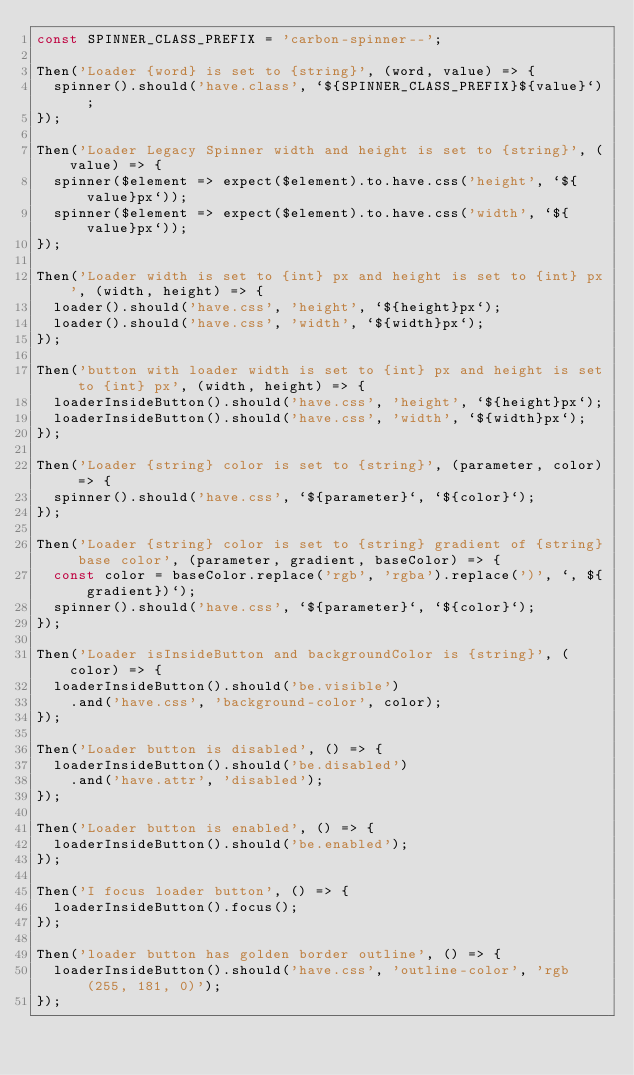Convert code to text. <code><loc_0><loc_0><loc_500><loc_500><_JavaScript_>const SPINNER_CLASS_PREFIX = 'carbon-spinner--';

Then('Loader {word} is set to {string}', (word, value) => {
  spinner().should('have.class', `${SPINNER_CLASS_PREFIX}${value}`);
});

Then('Loader Legacy Spinner width and height is set to {string}', (value) => {
  spinner($element => expect($element).to.have.css('height', `${value}px`));
  spinner($element => expect($element).to.have.css('width', `${value}px`));
});

Then('Loader width is set to {int} px and height is set to {int} px', (width, height) => {
  loader().should('have.css', 'height', `${height}px`);
  loader().should('have.css', 'width', `${width}px`);
});

Then('button with loader width is set to {int} px and height is set to {int} px', (width, height) => {
  loaderInsideButton().should('have.css', 'height', `${height}px`);
  loaderInsideButton().should('have.css', 'width', `${width}px`);
});

Then('Loader {string} color is set to {string}', (parameter, color) => {
  spinner().should('have.css', `${parameter}`, `${color}`);
});

Then('Loader {string} color is set to {string} gradient of {string} base color', (parameter, gradient, baseColor) => {
  const color = baseColor.replace('rgb', 'rgba').replace(')', `, ${gradient})`);
  spinner().should('have.css', `${parameter}`, `${color}`);
});

Then('Loader isInsideButton and backgroundColor is {string}', (color) => {
  loaderInsideButton().should('be.visible')
    .and('have.css', 'background-color', color);
});

Then('Loader button is disabled', () => {
  loaderInsideButton().should('be.disabled')
    .and('have.attr', 'disabled');
});

Then('Loader button is enabled', () => {
  loaderInsideButton().should('be.enabled');
});

Then('I focus loader button', () => {
  loaderInsideButton().focus();
});

Then('loader button has golden border outline', () => {
  loaderInsideButton().should('have.css', 'outline-color', 'rgb(255, 181, 0)');
});
</code> 